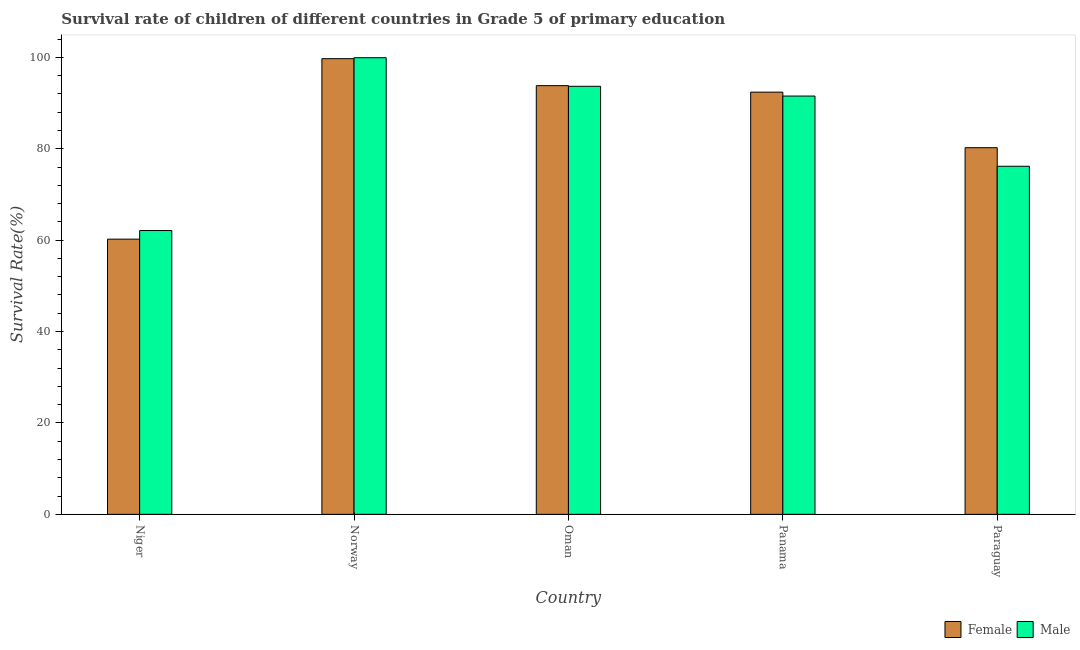How many different coloured bars are there?
Offer a terse response. 2. How many groups of bars are there?
Offer a terse response. 5. Are the number of bars per tick equal to the number of legend labels?
Provide a short and direct response. Yes. What is the label of the 5th group of bars from the left?
Your answer should be compact. Paraguay. In how many cases, is the number of bars for a given country not equal to the number of legend labels?
Your response must be concise. 0. What is the survival rate of male students in primary education in Oman?
Provide a short and direct response. 93.67. Across all countries, what is the maximum survival rate of female students in primary education?
Keep it short and to the point. 99.71. Across all countries, what is the minimum survival rate of female students in primary education?
Provide a short and direct response. 60.22. In which country was the survival rate of female students in primary education minimum?
Make the answer very short. Niger. What is the total survival rate of female students in primary education in the graph?
Your response must be concise. 426.36. What is the difference between the survival rate of female students in primary education in Niger and that in Panama?
Your answer should be very brief. -32.17. What is the difference between the survival rate of female students in primary education in Niger and the survival rate of male students in primary education in Norway?
Your answer should be compact. -39.71. What is the average survival rate of male students in primary education per country?
Keep it short and to the point. 84.68. What is the difference between the survival rate of female students in primary education and survival rate of male students in primary education in Niger?
Your answer should be compact. -1.88. What is the ratio of the survival rate of female students in primary education in Oman to that in Panama?
Offer a very short reply. 1.02. Is the survival rate of female students in primary education in Niger less than that in Norway?
Your answer should be compact. Yes. Is the difference between the survival rate of male students in primary education in Norway and Oman greater than the difference between the survival rate of female students in primary education in Norway and Oman?
Make the answer very short. Yes. What is the difference between the highest and the second highest survival rate of male students in primary education?
Your response must be concise. 6.26. What is the difference between the highest and the lowest survival rate of female students in primary education?
Give a very brief answer. 39.49. In how many countries, is the survival rate of male students in primary education greater than the average survival rate of male students in primary education taken over all countries?
Your answer should be compact. 3. Is the sum of the survival rate of male students in primary education in Niger and Oman greater than the maximum survival rate of female students in primary education across all countries?
Your response must be concise. Yes. What does the 2nd bar from the left in Panama represents?
Your answer should be compact. Male. What does the 2nd bar from the right in Paraguay represents?
Provide a succinct answer. Female. How many countries are there in the graph?
Your answer should be very brief. 5. Does the graph contain grids?
Your answer should be compact. No. Where does the legend appear in the graph?
Your answer should be very brief. Bottom right. How many legend labels are there?
Ensure brevity in your answer.  2. How are the legend labels stacked?
Provide a succinct answer. Horizontal. What is the title of the graph?
Give a very brief answer. Survival rate of children of different countries in Grade 5 of primary education. Does "Resident workers" appear as one of the legend labels in the graph?
Give a very brief answer. No. What is the label or title of the X-axis?
Make the answer very short. Country. What is the label or title of the Y-axis?
Offer a very short reply. Survival Rate(%). What is the Survival Rate(%) in Female in Niger?
Keep it short and to the point. 60.22. What is the Survival Rate(%) in Male in Niger?
Your answer should be very brief. 62.1. What is the Survival Rate(%) in Female in Norway?
Your response must be concise. 99.71. What is the Survival Rate(%) of Male in Norway?
Your answer should be very brief. 99.92. What is the Survival Rate(%) of Female in Oman?
Your answer should be very brief. 93.81. What is the Survival Rate(%) in Male in Oman?
Provide a short and direct response. 93.67. What is the Survival Rate(%) in Female in Panama?
Give a very brief answer. 92.39. What is the Survival Rate(%) in Male in Panama?
Your answer should be very brief. 91.53. What is the Survival Rate(%) in Female in Paraguay?
Offer a very short reply. 80.23. What is the Survival Rate(%) in Male in Paraguay?
Ensure brevity in your answer.  76.17. Across all countries, what is the maximum Survival Rate(%) of Female?
Offer a very short reply. 99.71. Across all countries, what is the maximum Survival Rate(%) of Male?
Provide a succinct answer. 99.92. Across all countries, what is the minimum Survival Rate(%) of Female?
Provide a short and direct response. 60.22. Across all countries, what is the minimum Survival Rate(%) in Male?
Offer a very short reply. 62.1. What is the total Survival Rate(%) of Female in the graph?
Keep it short and to the point. 426.36. What is the total Survival Rate(%) of Male in the graph?
Your answer should be very brief. 423.39. What is the difference between the Survival Rate(%) in Female in Niger and that in Norway?
Keep it short and to the point. -39.49. What is the difference between the Survival Rate(%) of Male in Niger and that in Norway?
Provide a short and direct response. -37.82. What is the difference between the Survival Rate(%) of Female in Niger and that in Oman?
Your answer should be compact. -33.59. What is the difference between the Survival Rate(%) in Male in Niger and that in Oman?
Make the answer very short. -31.57. What is the difference between the Survival Rate(%) in Female in Niger and that in Panama?
Offer a very short reply. -32.17. What is the difference between the Survival Rate(%) of Male in Niger and that in Panama?
Keep it short and to the point. -29.43. What is the difference between the Survival Rate(%) of Female in Niger and that in Paraguay?
Your response must be concise. -20.01. What is the difference between the Survival Rate(%) of Male in Niger and that in Paraguay?
Ensure brevity in your answer.  -14.06. What is the difference between the Survival Rate(%) of Female in Norway and that in Oman?
Your answer should be compact. 5.9. What is the difference between the Survival Rate(%) of Male in Norway and that in Oman?
Your response must be concise. 6.26. What is the difference between the Survival Rate(%) of Female in Norway and that in Panama?
Your answer should be compact. 7.33. What is the difference between the Survival Rate(%) of Male in Norway and that in Panama?
Your answer should be very brief. 8.39. What is the difference between the Survival Rate(%) in Female in Norway and that in Paraguay?
Provide a succinct answer. 19.48. What is the difference between the Survival Rate(%) in Male in Norway and that in Paraguay?
Offer a terse response. 23.76. What is the difference between the Survival Rate(%) of Female in Oman and that in Panama?
Give a very brief answer. 1.42. What is the difference between the Survival Rate(%) in Male in Oman and that in Panama?
Provide a succinct answer. 2.13. What is the difference between the Survival Rate(%) in Female in Oman and that in Paraguay?
Your response must be concise. 13.58. What is the difference between the Survival Rate(%) of Male in Oman and that in Paraguay?
Provide a short and direct response. 17.5. What is the difference between the Survival Rate(%) in Female in Panama and that in Paraguay?
Your response must be concise. 12.16. What is the difference between the Survival Rate(%) of Male in Panama and that in Paraguay?
Your response must be concise. 15.37. What is the difference between the Survival Rate(%) of Female in Niger and the Survival Rate(%) of Male in Norway?
Provide a short and direct response. -39.71. What is the difference between the Survival Rate(%) in Female in Niger and the Survival Rate(%) in Male in Oman?
Offer a very short reply. -33.45. What is the difference between the Survival Rate(%) of Female in Niger and the Survival Rate(%) of Male in Panama?
Offer a very short reply. -31.31. What is the difference between the Survival Rate(%) in Female in Niger and the Survival Rate(%) in Male in Paraguay?
Your answer should be compact. -15.95. What is the difference between the Survival Rate(%) of Female in Norway and the Survival Rate(%) of Male in Oman?
Give a very brief answer. 6.05. What is the difference between the Survival Rate(%) of Female in Norway and the Survival Rate(%) of Male in Panama?
Make the answer very short. 8.18. What is the difference between the Survival Rate(%) in Female in Norway and the Survival Rate(%) in Male in Paraguay?
Give a very brief answer. 23.55. What is the difference between the Survival Rate(%) in Female in Oman and the Survival Rate(%) in Male in Panama?
Your answer should be compact. 2.28. What is the difference between the Survival Rate(%) in Female in Oman and the Survival Rate(%) in Male in Paraguay?
Give a very brief answer. 17.65. What is the difference between the Survival Rate(%) of Female in Panama and the Survival Rate(%) of Male in Paraguay?
Keep it short and to the point. 16.22. What is the average Survival Rate(%) of Female per country?
Give a very brief answer. 85.27. What is the average Survival Rate(%) of Male per country?
Keep it short and to the point. 84.68. What is the difference between the Survival Rate(%) in Female and Survival Rate(%) in Male in Niger?
Ensure brevity in your answer.  -1.88. What is the difference between the Survival Rate(%) in Female and Survival Rate(%) in Male in Norway?
Offer a terse response. -0.21. What is the difference between the Survival Rate(%) of Female and Survival Rate(%) of Male in Oman?
Make the answer very short. 0.14. What is the difference between the Survival Rate(%) in Female and Survival Rate(%) in Male in Panama?
Your answer should be compact. 0.85. What is the difference between the Survival Rate(%) of Female and Survival Rate(%) of Male in Paraguay?
Provide a short and direct response. 4.06. What is the ratio of the Survival Rate(%) in Female in Niger to that in Norway?
Make the answer very short. 0.6. What is the ratio of the Survival Rate(%) in Male in Niger to that in Norway?
Your response must be concise. 0.62. What is the ratio of the Survival Rate(%) of Female in Niger to that in Oman?
Provide a short and direct response. 0.64. What is the ratio of the Survival Rate(%) in Male in Niger to that in Oman?
Offer a very short reply. 0.66. What is the ratio of the Survival Rate(%) of Female in Niger to that in Panama?
Provide a short and direct response. 0.65. What is the ratio of the Survival Rate(%) in Male in Niger to that in Panama?
Give a very brief answer. 0.68. What is the ratio of the Survival Rate(%) of Female in Niger to that in Paraguay?
Give a very brief answer. 0.75. What is the ratio of the Survival Rate(%) of Male in Niger to that in Paraguay?
Offer a terse response. 0.82. What is the ratio of the Survival Rate(%) of Female in Norway to that in Oman?
Provide a succinct answer. 1.06. What is the ratio of the Survival Rate(%) of Male in Norway to that in Oman?
Offer a very short reply. 1.07. What is the ratio of the Survival Rate(%) of Female in Norway to that in Panama?
Offer a terse response. 1.08. What is the ratio of the Survival Rate(%) in Male in Norway to that in Panama?
Give a very brief answer. 1.09. What is the ratio of the Survival Rate(%) of Female in Norway to that in Paraguay?
Your answer should be very brief. 1.24. What is the ratio of the Survival Rate(%) in Male in Norway to that in Paraguay?
Ensure brevity in your answer.  1.31. What is the ratio of the Survival Rate(%) in Female in Oman to that in Panama?
Your answer should be very brief. 1.02. What is the ratio of the Survival Rate(%) of Male in Oman to that in Panama?
Give a very brief answer. 1.02. What is the ratio of the Survival Rate(%) of Female in Oman to that in Paraguay?
Provide a succinct answer. 1.17. What is the ratio of the Survival Rate(%) in Male in Oman to that in Paraguay?
Offer a very short reply. 1.23. What is the ratio of the Survival Rate(%) of Female in Panama to that in Paraguay?
Your answer should be very brief. 1.15. What is the ratio of the Survival Rate(%) in Male in Panama to that in Paraguay?
Your answer should be very brief. 1.2. What is the difference between the highest and the second highest Survival Rate(%) in Female?
Keep it short and to the point. 5.9. What is the difference between the highest and the second highest Survival Rate(%) in Male?
Give a very brief answer. 6.26. What is the difference between the highest and the lowest Survival Rate(%) of Female?
Provide a succinct answer. 39.49. What is the difference between the highest and the lowest Survival Rate(%) in Male?
Offer a terse response. 37.82. 